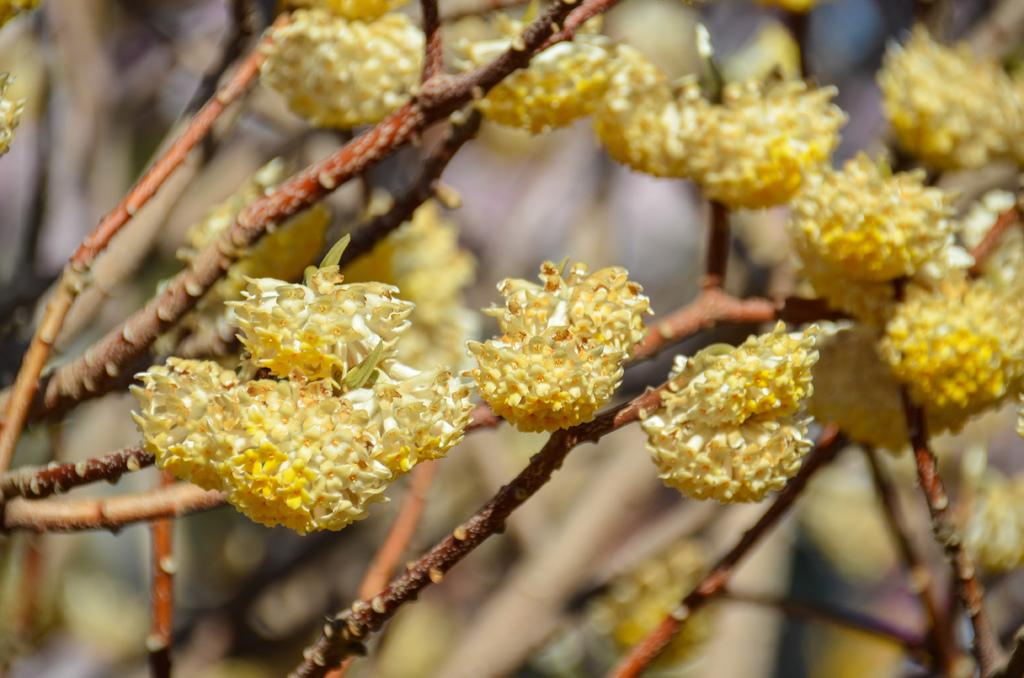What is the main object in the image? There is a tree in the image. What can be seen on the tree? There are yellow flowers on the tree. Can you describe the background of the image? The background of the image is blurry. Where is the father standing in the image? There is no father present in the image; it only features a tree with yellow flowers and a blurry background. 